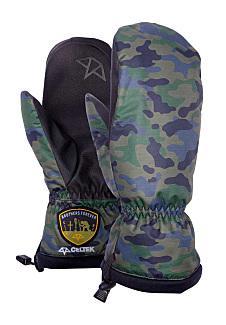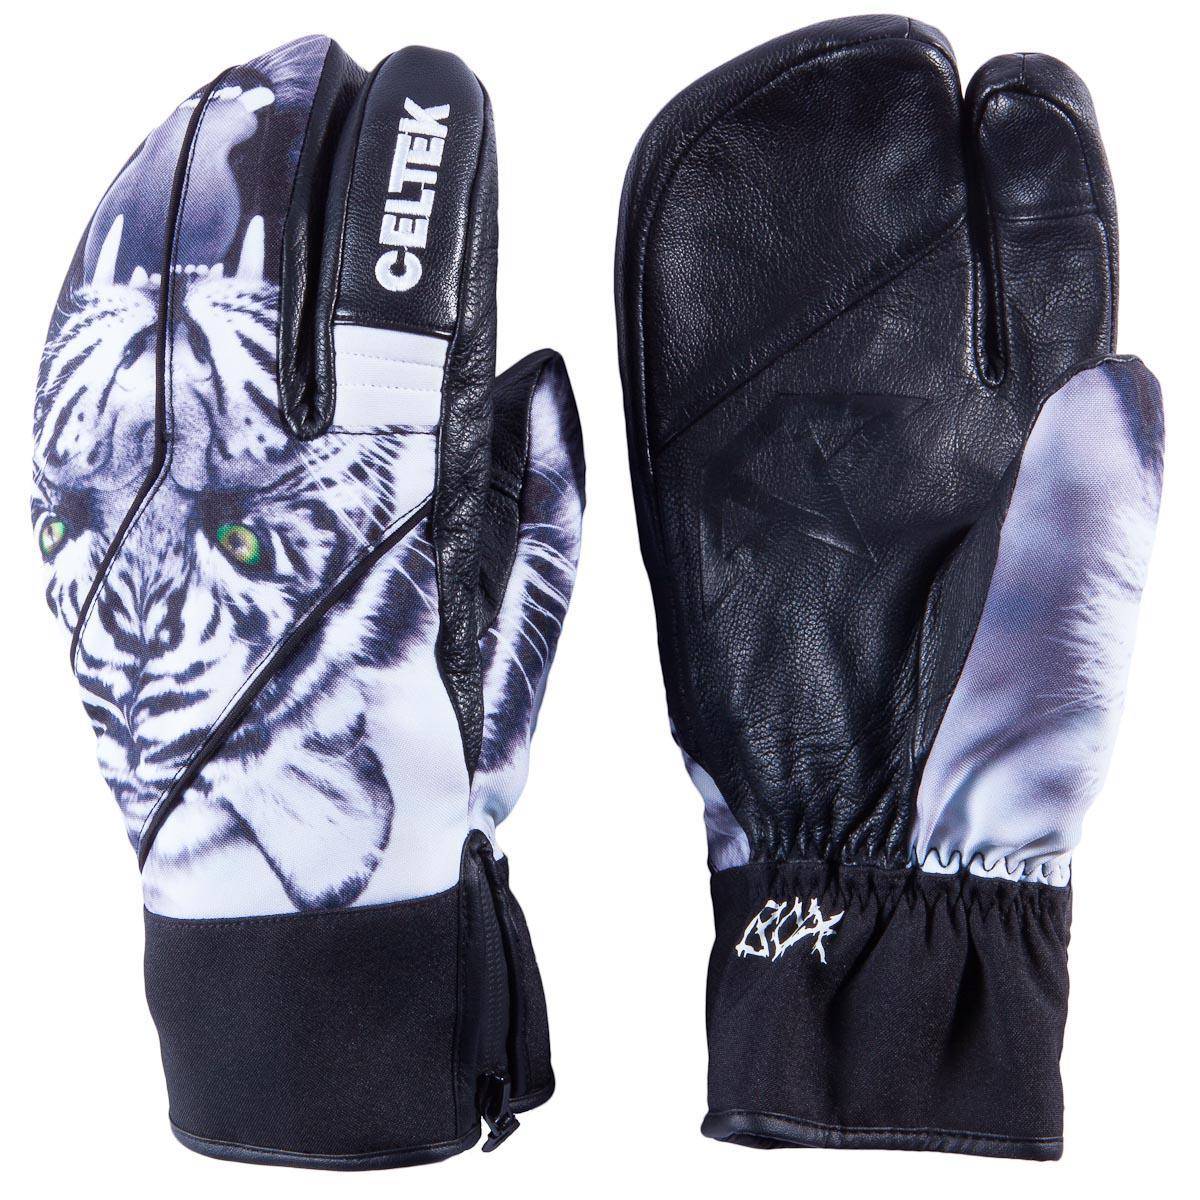The first image is the image on the left, the second image is the image on the right. Assess this claim about the two images: "The pattern on the mittens in the image on the right depict a nonhuman animal.". Correct or not? Answer yes or no. Yes. 